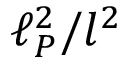<formula> <loc_0><loc_0><loc_500><loc_500>\ell _ { P } ^ { 2 } / l ^ { 2 }</formula> 